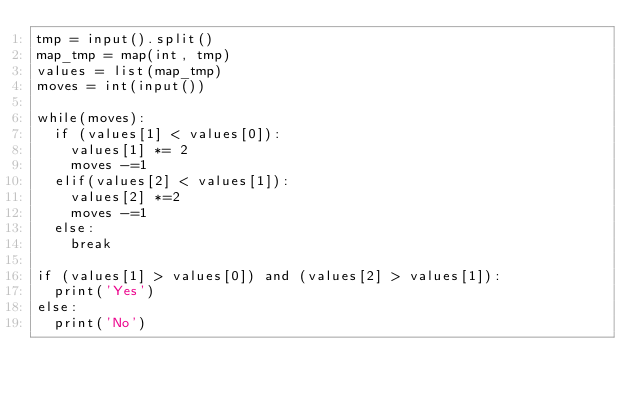Convert code to text. <code><loc_0><loc_0><loc_500><loc_500><_Python_>tmp = input().split()
map_tmp = map(int, tmp)
values = list(map_tmp)
moves = int(input())

while(moves):
  if (values[1] < values[0]):
  	values[1] *= 2
  	moves -=1
  elif(values[2] < values[1]):
    values[2] *=2
    moves -=1
  else:
    break
    
if (values[1] > values[0]) and (values[2] > values[1]):
  print('Yes')
else:
  print('No')
</code> 